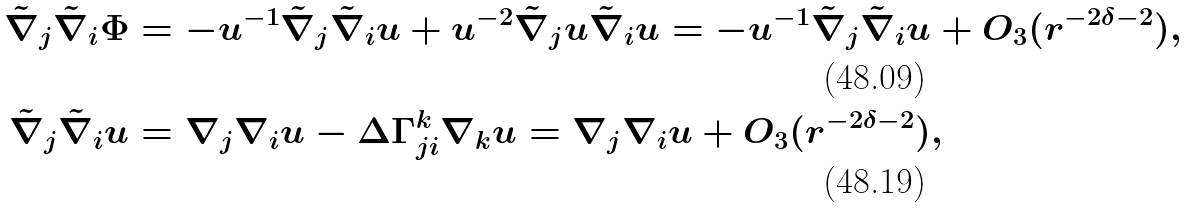<formula> <loc_0><loc_0><loc_500><loc_500>\tilde { \nabla } _ { j } \tilde { \nabla } _ { i } \Phi & = - u ^ { - 1 } \tilde { \nabla } _ { j } \tilde { \nabla } _ { i } u + u ^ { - 2 } \tilde { \nabla } _ { j } u \tilde { \nabla } _ { i } u = - u ^ { - 1 } \tilde { \nabla } _ { j } \tilde { \nabla } _ { i } u + O _ { 3 } ( r ^ { - 2 \delta - 2 } ) , \\ \tilde { \nabla } _ { j } \tilde { \nabla } _ { i } u & = \nabla _ { j } \nabla _ { i } u - \Delta \Gamma ^ { k } _ { j i } \nabla _ { k } u = \nabla _ { j } \nabla _ { i } u + O _ { 3 } ( r ^ { - 2 \delta - 2 } ) ,</formula> 